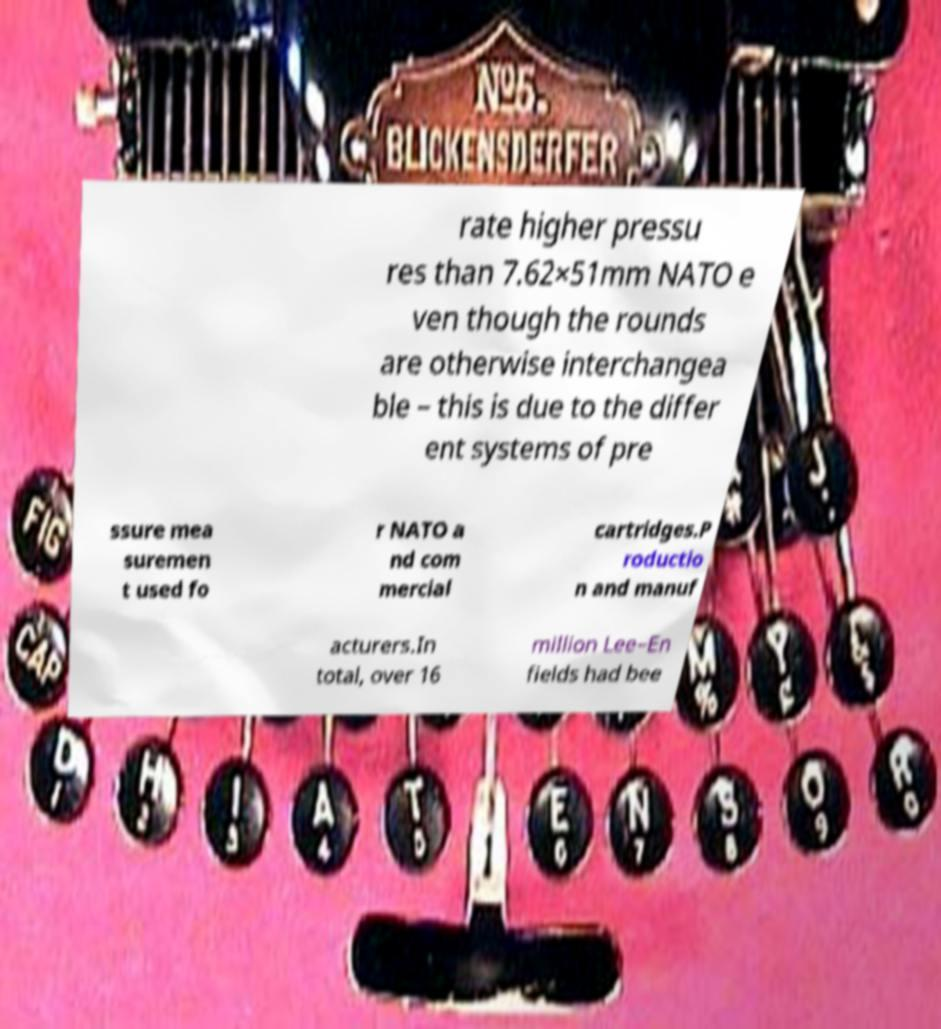I need the written content from this picture converted into text. Can you do that? rate higher pressu res than 7.62×51mm NATO e ven though the rounds are otherwise interchangea ble – this is due to the differ ent systems of pre ssure mea suremen t used fo r NATO a nd com mercial cartridges.P roductio n and manuf acturers.In total, over 16 million Lee–En fields had bee 